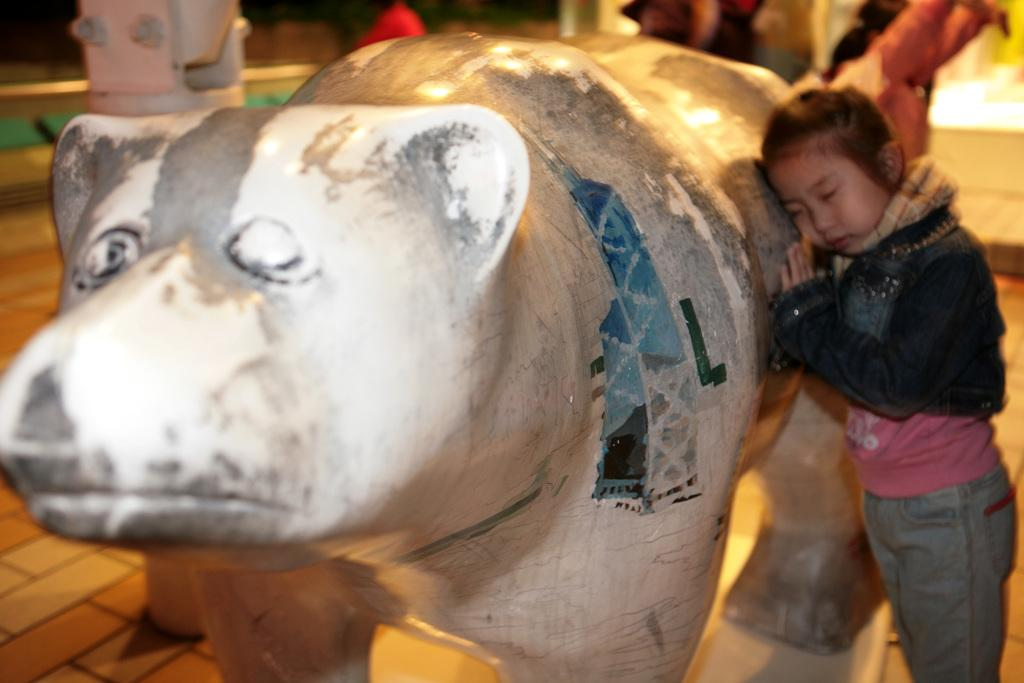Who is present in the image? There is a girl in the image. What is the girl standing beside? The girl is standing beside an animal statue. What color is the girl's t-shirt? The girl is wearing a pink t-shirt. What type of outerwear is the girl wearing? The girl is wearing a blue coat. What type of loaf is the girl holding in the image? There is no loaf or fire present in the image; the girl is standing beside an animal statue. 